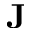Convert formula to latex. <formula><loc_0><loc_0><loc_500><loc_500>\mathbf J</formula> 